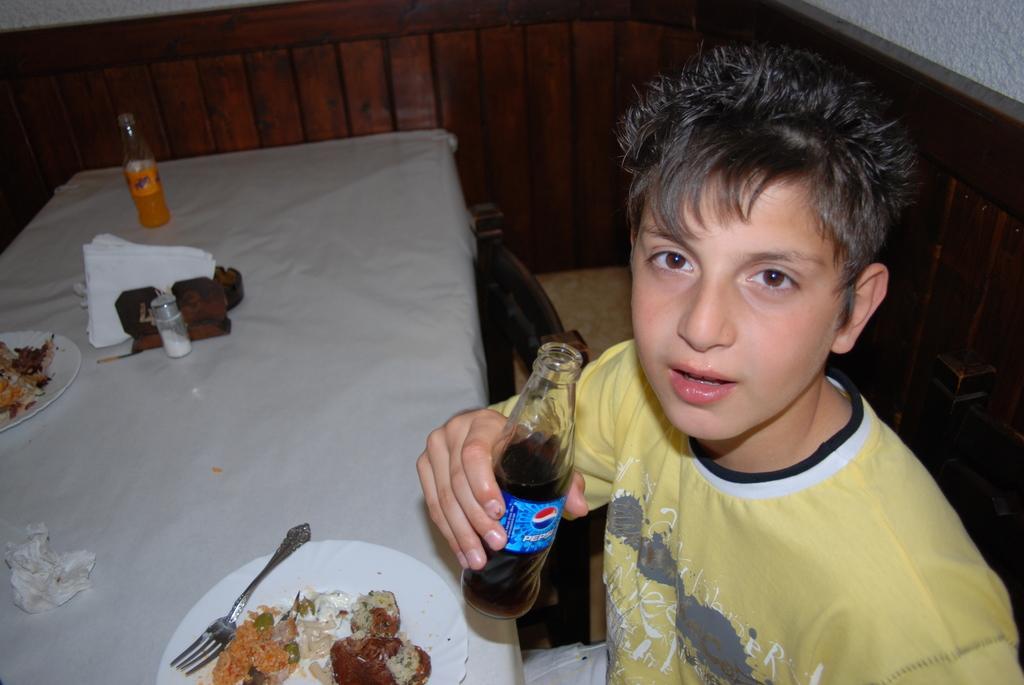Can you describe this image briefly? Bottom right side of the image a boy is sitting and holding a bottle. Behind him there is a wall. Bottom left side of the image there is a table on the table there is a plate, fork and there are some tissue papers and there are some bottles. 